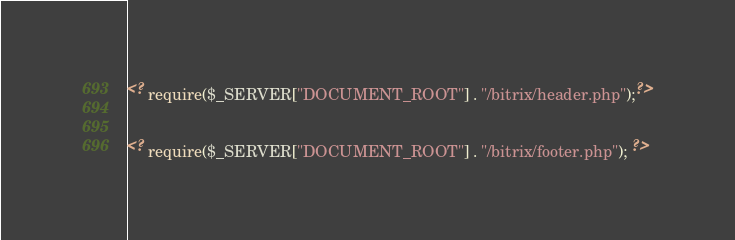<code> <loc_0><loc_0><loc_500><loc_500><_PHP_><? require($_SERVER["DOCUMENT_ROOT"] . "/bitrix/header.php");?>


<? require($_SERVER["DOCUMENT_ROOT"] . "/bitrix/footer.php"); ?></code> 